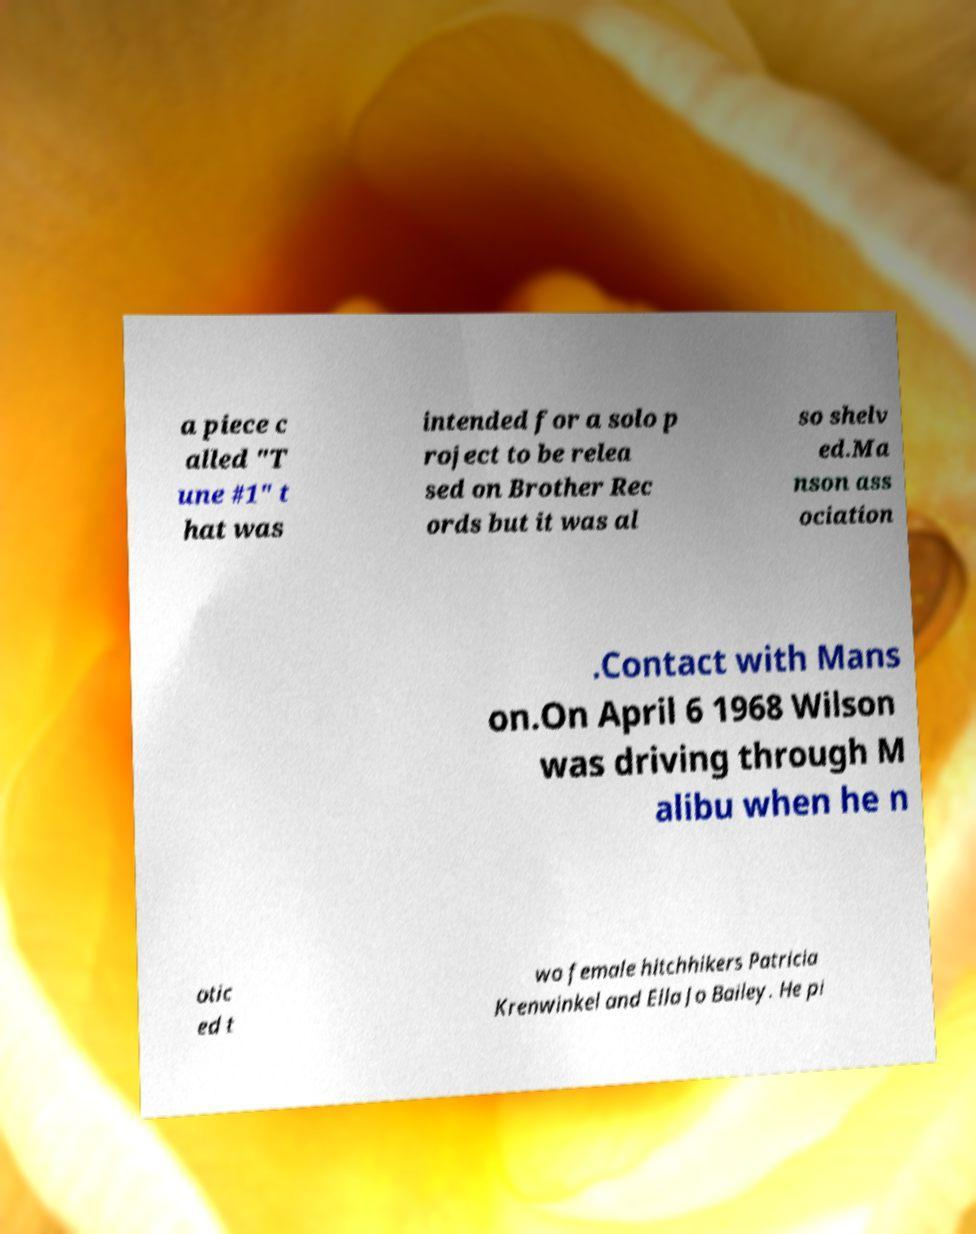For documentation purposes, I need the text within this image transcribed. Could you provide that? a piece c alled "T une #1" t hat was intended for a solo p roject to be relea sed on Brother Rec ords but it was al so shelv ed.Ma nson ass ociation .Contact with Mans on.On April 6 1968 Wilson was driving through M alibu when he n otic ed t wo female hitchhikers Patricia Krenwinkel and Ella Jo Bailey. He pi 